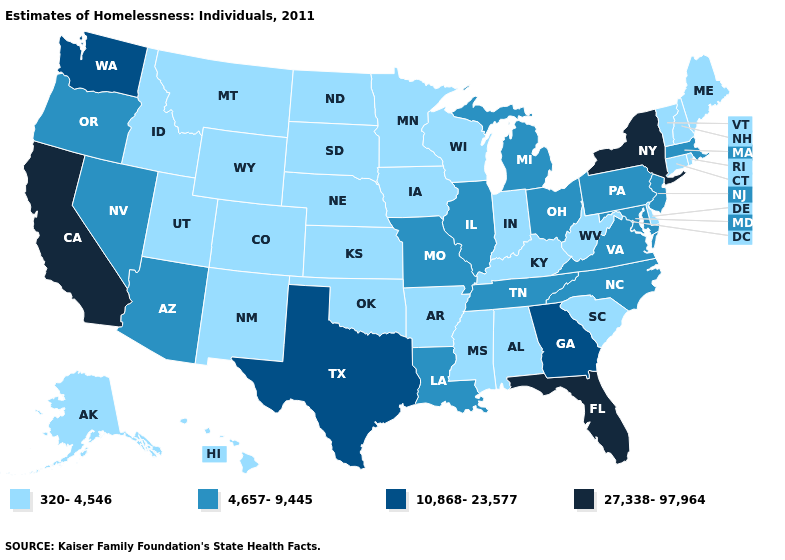Does Tennessee have a lower value than Oregon?
Write a very short answer. No. What is the value of Michigan?
Concise answer only. 4,657-9,445. Does the first symbol in the legend represent the smallest category?
Concise answer only. Yes. Which states have the highest value in the USA?
Be succinct. California, Florida, New York. Name the states that have a value in the range 27,338-97,964?
Write a very short answer. California, Florida, New York. What is the highest value in the MidWest ?
Keep it brief. 4,657-9,445. Name the states that have a value in the range 4,657-9,445?
Write a very short answer. Arizona, Illinois, Louisiana, Maryland, Massachusetts, Michigan, Missouri, Nevada, New Jersey, North Carolina, Ohio, Oregon, Pennsylvania, Tennessee, Virginia. What is the highest value in the Northeast ?
Be succinct. 27,338-97,964. What is the value of Alabama?
Keep it brief. 320-4,546. What is the lowest value in states that border New York?
Keep it brief. 320-4,546. Which states have the highest value in the USA?
Concise answer only. California, Florida, New York. Does Maryland have the lowest value in the USA?
Concise answer only. No. Name the states that have a value in the range 27,338-97,964?
Short answer required. California, Florida, New York. Which states have the highest value in the USA?
Answer briefly. California, Florida, New York. What is the highest value in the USA?
Give a very brief answer. 27,338-97,964. 